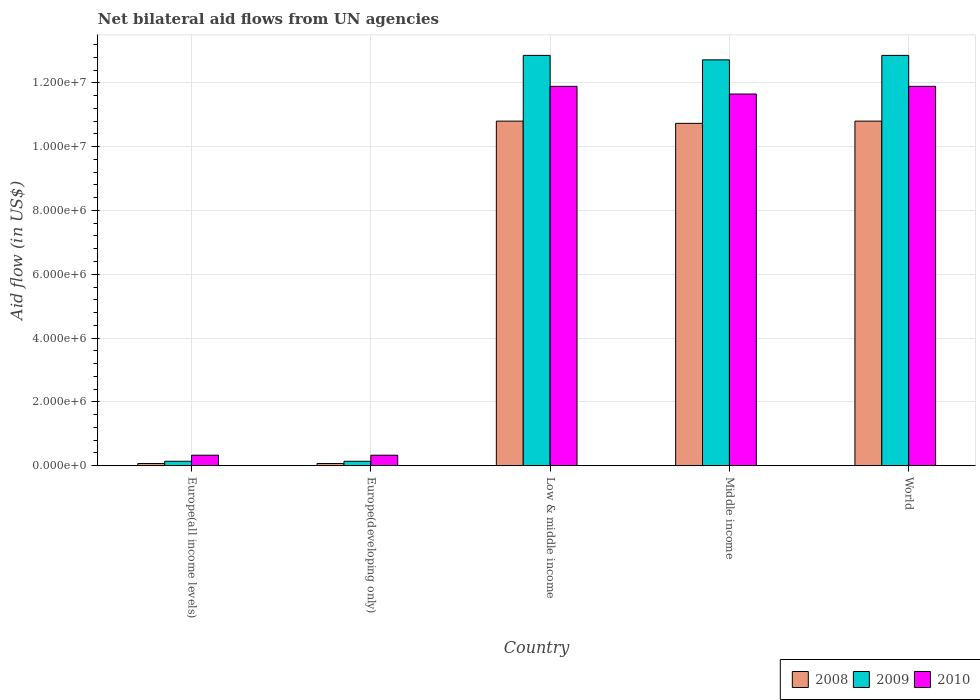Are the number of bars per tick equal to the number of legend labels?
Offer a very short reply. Yes. Are the number of bars on each tick of the X-axis equal?
Your response must be concise. Yes. How many bars are there on the 3rd tick from the left?
Your answer should be compact. 3. How many bars are there on the 1st tick from the right?
Your answer should be very brief. 3. What is the label of the 4th group of bars from the left?
Make the answer very short. Middle income. What is the net bilateral aid flow in 2008 in Europe(all income levels)?
Keep it short and to the point. 7.00e+04. Across all countries, what is the maximum net bilateral aid flow in 2009?
Your answer should be compact. 1.29e+07. Across all countries, what is the minimum net bilateral aid flow in 2008?
Offer a terse response. 7.00e+04. In which country was the net bilateral aid flow in 2010 maximum?
Ensure brevity in your answer.  Low & middle income. In which country was the net bilateral aid flow in 2009 minimum?
Give a very brief answer. Europe(all income levels). What is the total net bilateral aid flow in 2008 in the graph?
Keep it short and to the point. 3.25e+07. What is the difference between the net bilateral aid flow in 2009 in Europe(developing only) and that in Middle income?
Offer a terse response. -1.26e+07. What is the difference between the net bilateral aid flow in 2008 in World and the net bilateral aid flow in 2010 in Europe(developing only)?
Make the answer very short. 1.05e+07. What is the average net bilateral aid flow in 2009 per country?
Your response must be concise. 7.74e+06. What is the difference between the net bilateral aid flow of/in 2008 and net bilateral aid flow of/in 2010 in Middle income?
Provide a succinct answer. -9.20e+05. What is the ratio of the net bilateral aid flow in 2010 in Europe(developing only) to that in Middle income?
Ensure brevity in your answer.  0.03. Is the difference between the net bilateral aid flow in 2008 in Europe(all income levels) and Middle income greater than the difference between the net bilateral aid flow in 2010 in Europe(all income levels) and Middle income?
Provide a short and direct response. Yes. What is the difference between the highest and the lowest net bilateral aid flow in 2010?
Give a very brief answer. 1.16e+07. In how many countries, is the net bilateral aid flow in 2010 greater than the average net bilateral aid flow in 2010 taken over all countries?
Provide a short and direct response. 3. What does the 2nd bar from the left in World represents?
Offer a terse response. 2009. What is the difference between two consecutive major ticks on the Y-axis?
Make the answer very short. 2.00e+06. Are the values on the major ticks of Y-axis written in scientific E-notation?
Your answer should be very brief. Yes. Does the graph contain grids?
Give a very brief answer. Yes. Where does the legend appear in the graph?
Offer a terse response. Bottom right. How many legend labels are there?
Offer a very short reply. 3. What is the title of the graph?
Provide a succinct answer. Net bilateral aid flows from UN agencies. What is the label or title of the Y-axis?
Provide a short and direct response. Aid flow (in US$). What is the Aid flow (in US$) in 2010 in Europe(all income levels)?
Your answer should be compact. 3.30e+05. What is the Aid flow (in US$) in 2010 in Europe(developing only)?
Your answer should be compact. 3.30e+05. What is the Aid flow (in US$) of 2008 in Low & middle income?
Your answer should be compact. 1.08e+07. What is the Aid flow (in US$) in 2009 in Low & middle income?
Offer a very short reply. 1.29e+07. What is the Aid flow (in US$) of 2010 in Low & middle income?
Offer a terse response. 1.19e+07. What is the Aid flow (in US$) in 2008 in Middle income?
Your response must be concise. 1.07e+07. What is the Aid flow (in US$) in 2009 in Middle income?
Make the answer very short. 1.27e+07. What is the Aid flow (in US$) in 2010 in Middle income?
Offer a very short reply. 1.16e+07. What is the Aid flow (in US$) of 2008 in World?
Your response must be concise. 1.08e+07. What is the Aid flow (in US$) of 2009 in World?
Provide a succinct answer. 1.29e+07. What is the Aid flow (in US$) of 2010 in World?
Provide a succinct answer. 1.19e+07. Across all countries, what is the maximum Aid flow (in US$) in 2008?
Ensure brevity in your answer.  1.08e+07. Across all countries, what is the maximum Aid flow (in US$) in 2009?
Your response must be concise. 1.29e+07. Across all countries, what is the maximum Aid flow (in US$) in 2010?
Offer a very short reply. 1.19e+07. Across all countries, what is the minimum Aid flow (in US$) in 2009?
Offer a very short reply. 1.40e+05. What is the total Aid flow (in US$) of 2008 in the graph?
Keep it short and to the point. 3.25e+07. What is the total Aid flow (in US$) of 2009 in the graph?
Keep it short and to the point. 3.87e+07. What is the total Aid flow (in US$) in 2010 in the graph?
Provide a succinct answer. 3.61e+07. What is the difference between the Aid flow (in US$) in 2008 in Europe(all income levels) and that in Low & middle income?
Provide a short and direct response. -1.07e+07. What is the difference between the Aid flow (in US$) of 2009 in Europe(all income levels) and that in Low & middle income?
Offer a terse response. -1.27e+07. What is the difference between the Aid flow (in US$) of 2010 in Europe(all income levels) and that in Low & middle income?
Your answer should be compact. -1.16e+07. What is the difference between the Aid flow (in US$) in 2008 in Europe(all income levels) and that in Middle income?
Your response must be concise. -1.07e+07. What is the difference between the Aid flow (in US$) of 2009 in Europe(all income levels) and that in Middle income?
Provide a short and direct response. -1.26e+07. What is the difference between the Aid flow (in US$) of 2010 in Europe(all income levels) and that in Middle income?
Make the answer very short. -1.13e+07. What is the difference between the Aid flow (in US$) of 2008 in Europe(all income levels) and that in World?
Make the answer very short. -1.07e+07. What is the difference between the Aid flow (in US$) in 2009 in Europe(all income levels) and that in World?
Offer a very short reply. -1.27e+07. What is the difference between the Aid flow (in US$) of 2010 in Europe(all income levels) and that in World?
Make the answer very short. -1.16e+07. What is the difference between the Aid flow (in US$) of 2008 in Europe(developing only) and that in Low & middle income?
Make the answer very short. -1.07e+07. What is the difference between the Aid flow (in US$) in 2009 in Europe(developing only) and that in Low & middle income?
Your response must be concise. -1.27e+07. What is the difference between the Aid flow (in US$) in 2010 in Europe(developing only) and that in Low & middle income?
Offer a very short reply. -1.16e+07. What is the difference between the Aid flow (in US$) of 2008 in Europe(developing only) and that in Middle income?
Ensure brevity in your answer.  -1.07e+07. What is the difference between the Aid flow (in US$) in 2009 in Europe(developing only) and that in Middle income?
Offer a very short reply. -1.26e+07. What is the difference between the Aid flow (in US$) of 2010 in Europe(developing only) and that in Middle income?
Keep it short and to the point. -1.13e+07. What is the difference between the Aid flow (in US$) in 2008 in Europe(developing only) and that in World?
Your answer should be very brief. -1.07e+07. What is the difference between the Aid flow (in US$) of 2009 in Europe(developing only) and that in World?
Keep it short and to the point. -1.27e+07. What is the difference between the Aid flow (in US$) in 2010 in Europe(developing only) and that in World?
Your response must be concise. -1.16e+07. What is the difference between the Aid flow (in US$) in 2008 in Low & middle income and that in Middle income?
Your response must be concise. 7.00e+04. What is the difference between the Aid flow (in US$) of 2010 in Low & middle income and that in Middle income?
Keep it short and to the point. 2.40e+05. What is the difference between the Aid flow (in US$) of 2009 in Low & middle income and that in World?
Make the answer very short. 0. What is the difference between the Aid flow (in US$) of 2009 in Middle income and that in World?
Offer a terse response. -1.40e+05. What is the difference between the Aid flow (in US$) of 2010 in Middle income and that in World?
Ensure brevity in your answer.  -2.40e+05. What is the difference between the Aid flow (in US$) in 2008 in Europe(all income levels) and the Aid flow (in US$) in 2010 in Europe(developing only)?
Provide a short and direct response. -2.60e+05. What is the difference between the Aid flow (in US$) of 2009 in Europe(all income levels) and the Aid flow (in US$) of 2010 in Europe(developing only)?
Make the answer very short. -1.90e+05. What is the difference between the Aid flow (in US$) of 2008 in Europe(all income levels) and the Aid flow (in US$) of 2009 in Low & middle income?
Keep it short and to the point. -1.28e+07. What is the difference between the Aid flow (in US$) of 2008 in Europe(all income levels) and the Aid flow (in US$) of 2010 in Low & middle income?
Ensure brevity in your answer.  -1.18e+07. What is the difference between the Aid flow (in US$) in 2009 in Europe(all income levels) and the Aid flow (in US$) in 2010 in Low & middle income?
Your answer should be compact. -1.18e+07. What is the difference between the Aid flow (in US$) in 2008 in Europe(all income levels) and the Aid flow (in US$) in 2009 in Middle income?
Provide a succinct answer. -1.26e+07. What is the difference between the Aid flow (in US$) in 2008 in Europe(all income levels) and the Aid flow (in US$) in 2010 in Middle income?
Provide a short and direct response. -1.16e+07. What is the difference between the Aid flow (in US$) of 2009 in Europe(all income levels) and the Aid flow (in US$) of 2010 in Middle income?
Offer a terse response. -1.15e+07. What is the difference between the Aid flow (in US$) of 2008 in Europe(all income levels) and the Aid flow (in US$) of 2009 in World?
Offer a very short reply. -1.28e+07. What is the difference between the Aid flow (in US$) of 2008 in Europe(all income levels) and the Aid flow (in US$) of 2010 in World?
Provide a succinct answer. -1.18e+07. What is the difference between the Aid flow (in US$) of 2009 in Europe(all income levels) and the Aid flow (in US$) of 2010 in World?
Your answer should be compact. -1.18e+07. What is the difference between the Aid flow (in US$) in 2008 in Europe(developing only) and the Aid flow (in US$) in 2009 in Low & middle income?
Your answer should be compact. -1.28e+07. What is the difference between the Aid flow (in US$) in 2008 in Europe(developing only) and the Aid flow (in US$) in 2010 in Low & middle income?
Offer a very short reply. -1.18e+07. What is the difference between the Aid flow (in US$) of 2009 in Europe(developing only) and the Aid flow (in US$) of 2010 in Low & middle income?
Provide a short and direct response. -1.18e+07. What is the difference between the Aid flow (in US$) of 2008 in Europe(developing only) and the Aid flow (in US$) of 2009 in Middle income?
Offer a terse response. -1.26e+07. What is the difference between the Aid flow (in US$) of 2008 in Europe(developing only) and the Aid flow (in US$) of 2010 in Middle income?
Ensure brevity in your answer.  -1.16e+07. What is the difference between the Aid flow (in US$) of 2009 in Europe(developing only) and the Aid flow (in US$) of 2010 in Middle income?
Your answer should be compact. -1.15e+07. What is the difference between the Aid flow (in US$) in 2008 in Europe(developing only) and the Aid flow (in US$) in 2009 in World?
Ensure brevity in your answer.  -1.28e+07. What is the difference between the Aid flow (in US$) in 2008 in Europe(developing only) and the Aid flow (in US$) in 2010 in World?
Provide a short and direct response. -1.18e+07. What is the difference between the Aid flow (in US$) in 2009 in Europe(developing only) and the Aid flow (in US$) in 2010 in World?
Provide a succinct answer. -1.18e+07. What is the difference between the Aid flow (in US$) in 2008 in Low & middle income and the Aid flow (in US$) in 2009 in Middle income?
Provide a short and direct response. -1.92e+06. What is the difference between the Aid flow (in US$) in 2008 in Low & middle income and the Aid flow (in US$) in 2010 in Middle income?
Ensure brevity in your answer.  -8.50e+05. What is the difference between the Aid flow (in US$) of 2009 in Low & middle income and the Aid flow (in US$) of 2010 in Middle income?
Your answer should be very brief. 1.21e+06. What is the difference between the Aid flow (in US$) in 2008 in Low & middle income and the Aid flow (in US$) in 2009 in World?
Ensure brevity in your answer.  -2.06e+06. What is the difference between the Aid flow (in US$) in 2008 in Low & middle income and the Aid flow (in US$) in 2010 in World?
Your answer should be compact. -1.09e+06. What is the difference between the Aid flow (in US$) in 2009 in Low & middle income and the Aid flow (in US$) in 2010 in World?
Offer a very short reply. 9.70e+05. What is the difference between the Aid flow (in US$) in 2008 in Middle income and the Aid flow (in US$) in 2009 in World?
Give a very brief answer. -2.13e+06. What is the difference between the Aid flow (in US$) of 2008 in Middle income and the Aid flow (in US$) of 2010 in World?
Provide a short and direct response. -1.16e+06. What is the difference between the Aid flow (in US$) in 2009 in Middle income and the Aid flow (in US$) in 2010 in World?
Your answer should be compact. 8.30e+05. What is the average Aid flow (in US$) in 2008 per country?
Provide a succinct answer. 6.49e+06. What is the average Aid flow (in US$) of 2009 per country?
Your response must be concise. 7.74e+06. What is the average Aid flow (in US$) of 2010 per country?
Provide a short and direct response. 7.22e+06. What is the difference between the Aid flow (in US$) of 2008 and Aid flow (in US$) of 2009 in Europe(all income levels)?
Your response must be concise. -7.00e+04. What is the difference between the Aid flow (in US$) of 2008 and Aid flow (in US$) of 2010 in Europe(all income levels)?
Your response must be concise. -2.60e+05. What is the difference between the Aid flow (in US$) in 2008 and Aid flow (in US$) in 2009 in Europe(developing only)?
Make the answer very short. -7.00e+04. What is the difference between the Aid flow (in US$) of 2008 and Aid flow (in US$) of 2010 in Europe(developing only)?
Your response must be concise. -2.60e+05. What is the difference between the Aid flow (in US$) in 2009 and Aid flow (in US$) in 2010 in Europe(developing only)?
Your answer should be compact. -1.90e+05. What is the difference between the Aid flow (in US$) in 2008 and Aid flow (in US$) in 2009 in Low & middle income?
Provide a short and direct response. -2.06e+06. What is the difference between the Aid flow (in US$) in 2008 and Aid flow (in US$) in 2010 in Low & middle income?
Give a very brief answer. -1.09e+06. What is the difference between the Aid flow (in US$) in 2009 and Aid flow (in US$) in 2010 in Low & middle income?
Make the answer very short. 9.70e+05. What is the difference between the Aid flow (in US$) of 2008 and Aid flow (in US$) of 2009 in Middle income?
Your answer should be very brief. -1.99e+06. What is the difference between the Aid flow (in US$) in 2008 and Aid flow (in US$) in 2010 in Middle income?
Ensure brevity in your answer.  -9.20e+05. What is the difference between the Aid flow (in US$) in 2009 and Aid flow (in US$) in 2010 in Middle income?
Make the answer very short. 1.07e+06. What is the difference between the Aid flow (in US$) in 2008 and Aid flow (in US$) in 2009 in World?
Your answer should be compact. -2.06e+06. What is the difference between the Aid flow (in US$) in 2008 and Aid flow (in US$) in 2010 in World?
Offer a very short reply. -1.09e+06. What is the difference between the Aid flow (in US$) in 2009 and Aid flow (in US$) in 2010 in World?
Give a very brief answer. 9.70e+05. What is the ratio of the Aid flow (in US$) in 2008 in Europe(all income levels) to that in Europe(developing only)?
Give a very brief answer. 1. What is the ratio of the Aid flow (in US$) in 2010 in Europe(all income levels) to that in Europe(developing only)?
Your answer should be compact. 1. What is the ratio of the Aid flow (in US$) of 2008 in Europe(all income levels) to that in Low & middle income?
Keep it short and to the point. 0.01. What is the ratio of the Aid flow (in US$) of 2009 in Europe(all income levels) to that in Low & middle income?
Offer a very short reply. 0.01. What is the ratio of the Aid flow (in US$) of 2010 in Europe(all income levels) to that in Low & middle income?
Provide a succinct answer. 0.03. What is the ratio of the Aid flow (in US$) of 2008 in Europe(all income levels) to that in Middle income?
Offer a terse response. 0.01. What is the ratio of the Aid flow (in US$) of 2009 in Europe(all income levels) to that in Middle income?
Your answer should be very brief. 0.01. What is the ratio of the Aid flow (in US$) of 2010 in Europe(all income levels) to that in Middle income?
Keep it short and to the point. 0.03. What is the ratio of the Aid flow (in US$) in 2008 in Europe(all income levels) to that in World?
Keep it short and to the point. 0.01. What is the ratio of the Aid flow (in US$) in 2009 in Europe(all income levels) to that in World?
Give a very brief answer. 0.01. What is the ratio of the Aid flow (in US$) in 2010 in Europe(all income levels) to that in World?
Ensure brevity in your answer.  0.03. What is the ratio of the Aid flow (in US$) of 2008 in Europe(developing only) to that in Low & middle income?
Your answer should be very brief. 0.01. What is the ratio of the Aid flow (in US$) of 2009 in Europe(developing only) to that in Low & middle income?
Your answer should be compact. 0.01. What is the ratio of the Aid flow (in US$) of 2010 in Europe(developing only) to that in Low & middle income?
Your answer should be very brief. 0.03. What is the ratio of the Aid flow (in US$) in 2008 in Europe(developing only) to that in Middle income?
Keep it short and to the point. 0.01. What is the ratio of the Aid flow (in US$) in 2009 in Europe(developing only) to that in Middle income?
Your answer should be compact. 0.01. What is the ratio of the Aid flow (in US$) in 2010 in Europe(developing only) to that in Middle income?
Keep it short and to the point. 0.03. What is the ratio of the Aid flow (in US$) of 2008 in Europe(developing only) to that in World?
Offer a very short reply. 0.01. What is the ratio of the Aid flow (in US$) in 2009 in Europe(developing only) to that in World?
Keep it short and to the point. 0.01. What is the ratio of the Aid flow (in US$) of 2010 in Europe(developing only) to that in World?
Provide a succinct answer. 0.03. What is the ratio of the Aid flow (in US$) in 2008 in Low & middle income to that in Middle income?
Your answer should be very brief. 1.01. What is the ratio of the Aid flow (in US$) of 2009 in Low & middle income to that in Middle income?
Your response must be concise. 1.01. What is the ratio of the Aid flow (in US$) in 2010 in Low & middle income to that in Middle income?
Offer a terse response. 1.02. What is the ratio of the Aid flow (in US$) in 2008 in Low & middle income to that in World?
Provide a short and direct response. 1. What is the ratio of the Aid flow (in US$) in 2009 in Low & middle income to that in World?
Give a very brief answer. 1. What is the ratio of the Aid flow (in US$) of 2008 in Middle income to that in World?
Ensure brevity in your answer.  0.99. What is the ratio of the Aid flow (in US$) of 2009 in Middle income to that in World?
Give a very brief answer. 0.99. What is the ratio of the Aid flow (in US$) of 2010 in Middle income to that in World?
Your answer should be compact. 0.98. What is the difference between the highest and the second highest Aid flow (in US$) in 2010?
Ensure brevity in your answer.  0. What is the difference between the highest and the lowest Aid flow (in US$) in 2008?
Ensure brevity in your answer.  1.07e+07. What is the difference between the highest and the lowest Aid flow (in US$) of 2009?
Make the answer very short. 1.27e+07. What is the difference between the highest and the lowest Aid flow (in US$) of 2010?
Make the answer very short. 1.16e+07. 